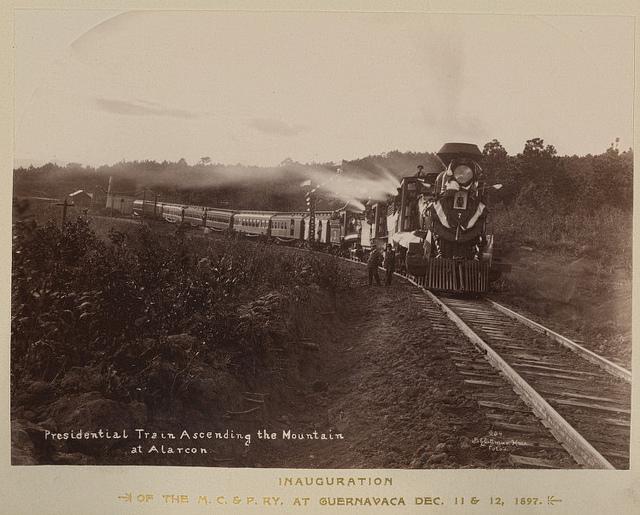Is this a color or black and white picture?
Quick response, please. Black and white. Are the metal lines parallel, perpendicular, or neither?
Keep it brief. Parallel. What is this train commemorating?
Be succinct. Inauguration. What types of activities are being conducted on the railway?
Quick response, please. Inauguration. 